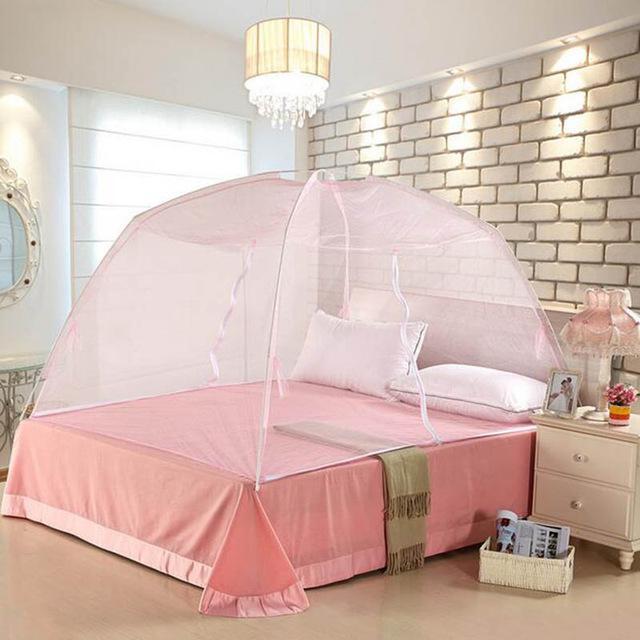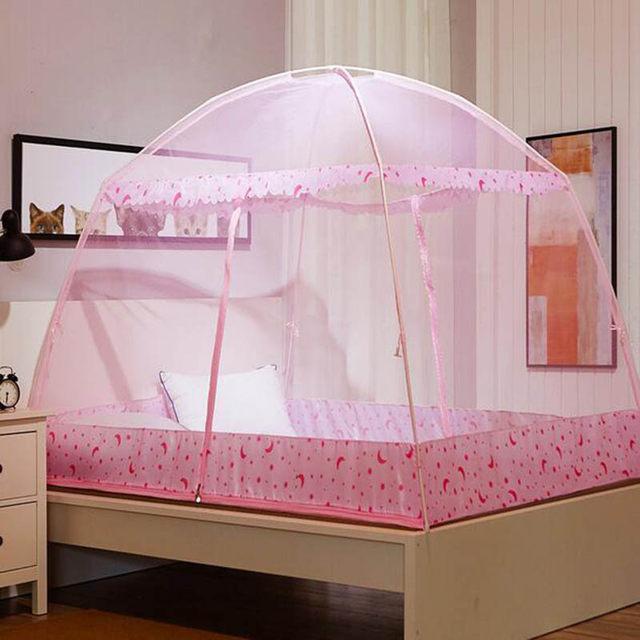The first image is the image on the left, the second image is the image on the right. Evaluate the accuracy of this statement regarding the images: "The left and right image contains a total of two pink canopies.". Is it true? Answer yes or no. Yes. The first image is the image on the left, the second image is the image on the right. Analyze the images presented: Is the assertion "All the bed nets are pink." valid? Answer yes or no. Yes. 